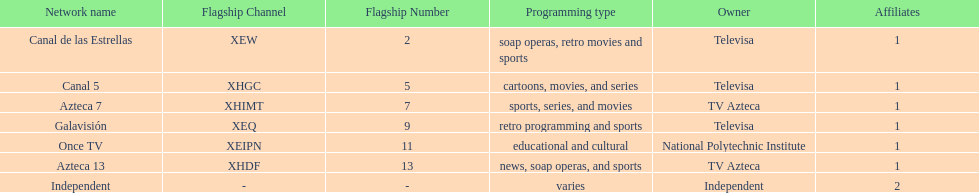How many networks does tv azteca own? 2. 